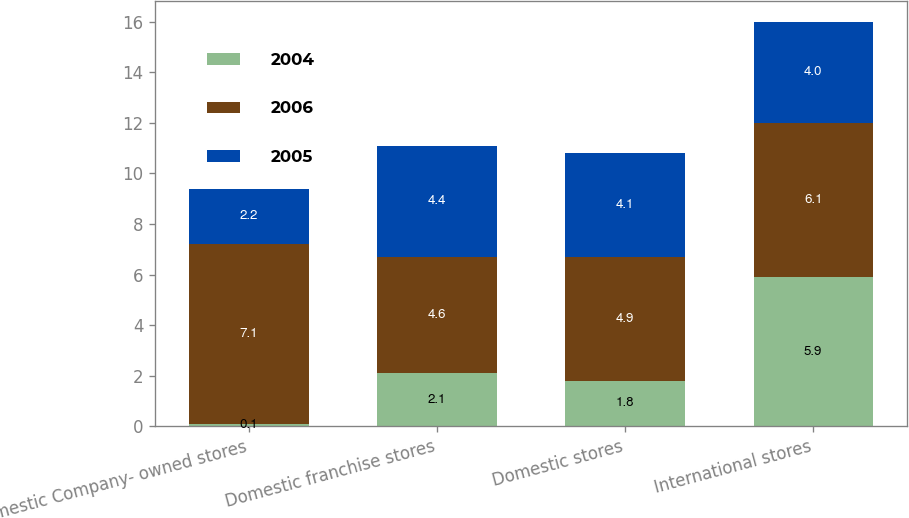Convert chart to OTSL. <chart><loc_0><loc_0><loc_500><loc_500><stacked_bar_chart><ecel><fcel>Domestic Company- owned stores<fcel>Domestic franchise stores<fcel>Domestic stores<fcel>International stores<nl><fcel>2004<fcel>0.1<fcel>2.1<fcel>1.8<fcel>5.9<nl><fcel>2006<fcel>7.1<fcel>4.6<fcel>4.9<fcel>6.1<nl><fcel>2005<fcel>2.2<fcel>4.4<fcel>4.1<fcel>4<nl></chart> 